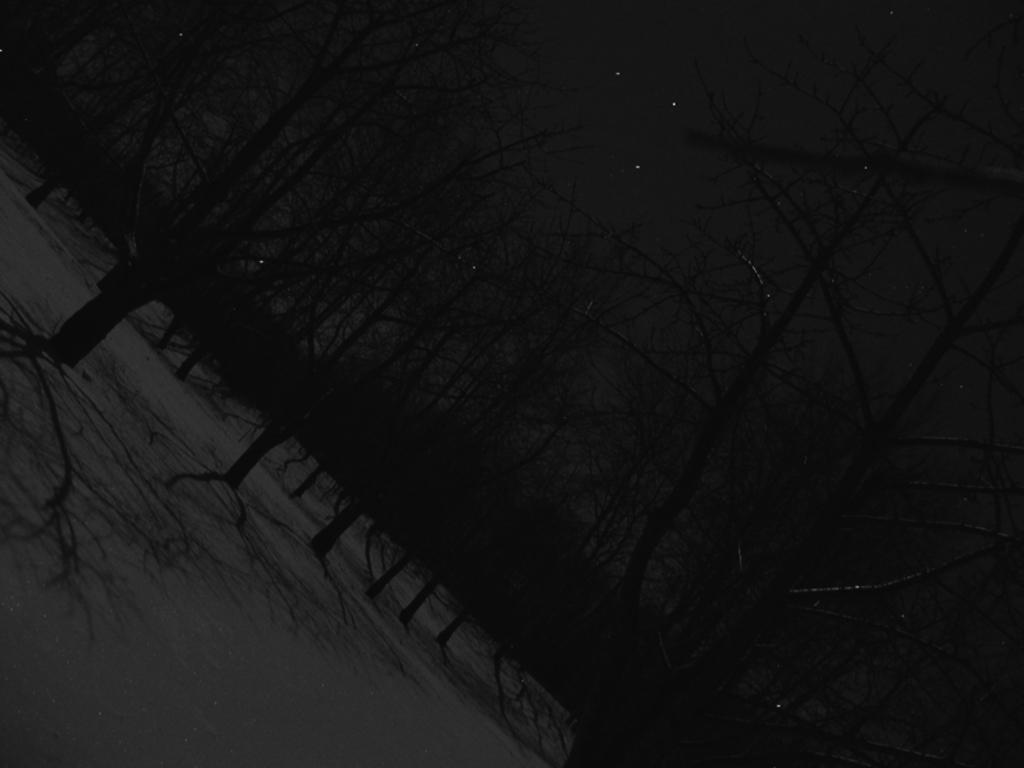Describe this image in one or two sentences. This picture shows bunch of trees and we see stars in the sky. This picture is taken in the dark. 